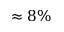Convert formula to latex. <formula><loc_0><loc_0><loc_500><loc_500>\approx 8 \%</formula> 